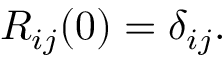Convert formula to latex. <formula><loc_0><loc_0><loc_500><loc_500>\begin{array} { r } { R _ { i j } ( 0 ) = \delta _ { i j } . } \end{array}</formula> 